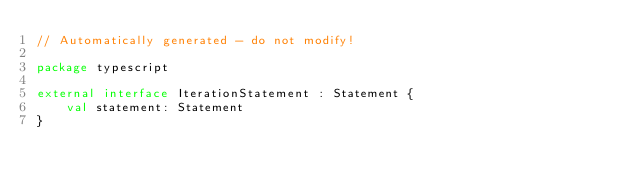Convert code to text. <code><loc_0><loc_0><loc_500><loc_500><_Kotlin_>// Automatically generated - do not modify!

package typescript

external interface IterationStatement : Statement {
    val statement: Statement
}
</code> 